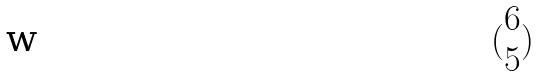<formula> <loc_0><loc_0><loc_500><loc_500>( \begin{matrix} 6 \\ 5 \end{matrix} )</formula> 